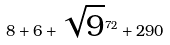Convert formula to latex. <formula><loc_0><loc_0><loc_500><loc_500>8 + 6 + \sqrt { 9 } ^ { 7 2 } + 2 9 0</formula> 